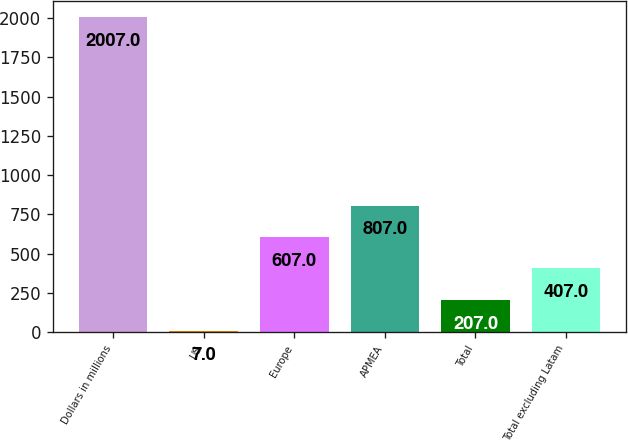Convert chart to OTSL. <chart><loc_0><loc_0><loc_500><loc_500><bar_chart><fcel>Dollars in millions<fcel>US<fcel>Europe<fcel>APMEA<fcel>Total<fcel>Total excluding Latam<nl><fcel>2007<fcel>7<fcel>607<fcel>807<fcel>207<fcel>407<nl></chart> 